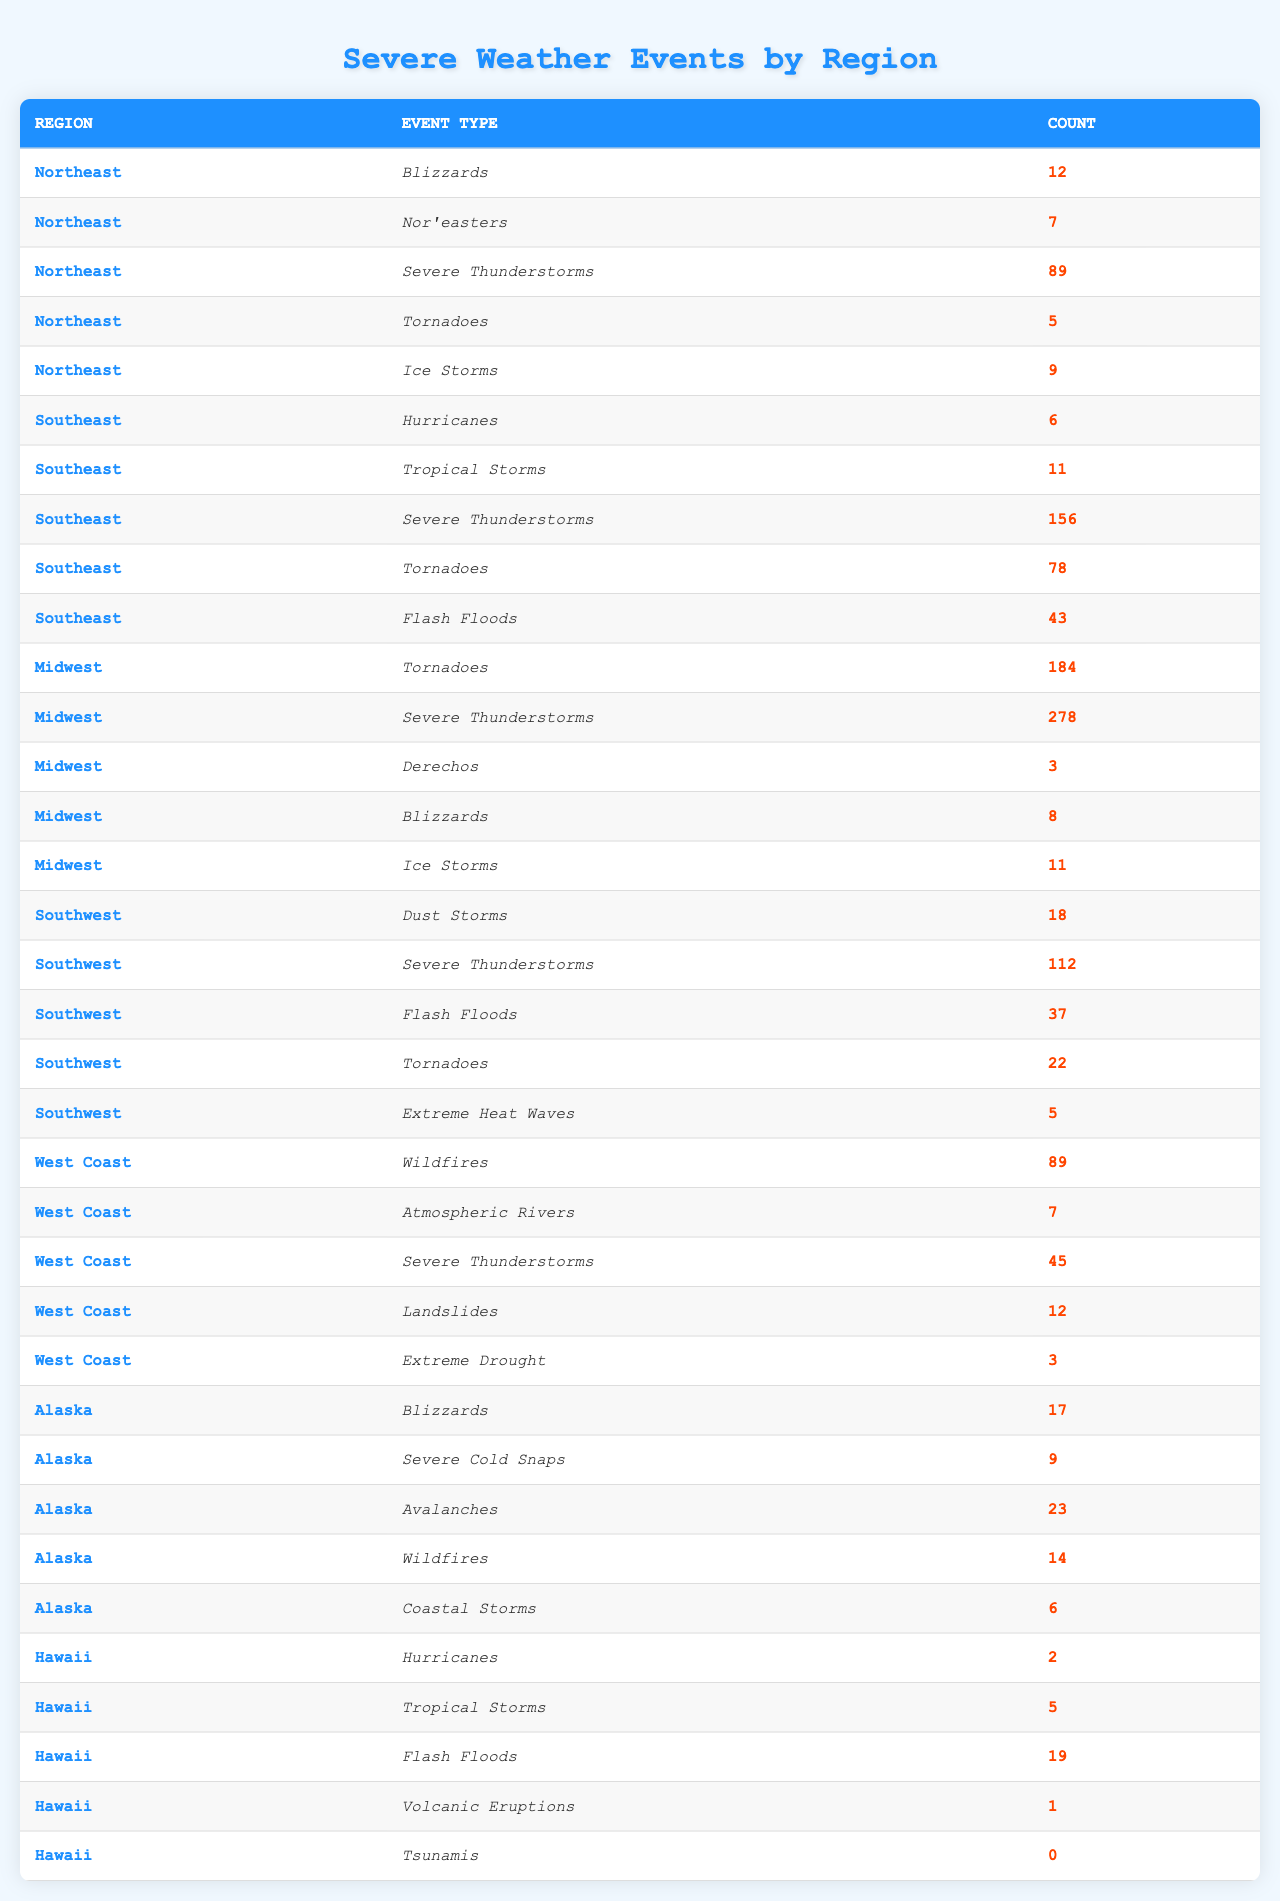What is the total number of severe thunderstorms reported in the Southeast? There are two entries for severe thunderstorms in the Southeast: 156 from Severe Thunderstorms and 78 from Tornadoes, which do not count as thunderstorms. So, the total for severe thunderstorms is simply 156.
Answer: 156 Which region experienced the highest number of tornadoes? In the table, the Midwest shows 184 tornadoes, more than any other region, as the Southeast has 78 and the Southwest has 22.
Answer: Midwest What is the total number of blizzards across all regions? In the Northeast there are 12 blizzards, in the Midwest there are 8, and in Alaska there are 17. Adding these gives 12 + 8 + 17 = 37.
Answer: 37 Were there any tornadoes reported in Hawaii? The table shows that Hawaii has no entries for tornadoes, as it only lists Hurricanes, Tropical Storms, Flash Floods, Volcanic Eruptions, and Tsunamis.
Answer: No Which region had the highest total count of severe weather events? First, we calculate the total events for each region: Northeast (122), Southeast (294), Midwest (484), Southwest (289), West Coast (156), Alaska (69), and Hawaii (27). The Midwest has the highest total with 484.
Answer: Midwest How many more severe thunderstorms occurred in the Southeast compared to the West Coast? The Southeast had 156 severe thunderstorms while the West Coast had 45. The difference is 156 - 45 = 111.
Answer: 111 What percentage of all reported tornadoes were in the Midwest? The Midwest reported 184 tornadoes, the Southeast reported 78, and the Southwest reported 22. The total is 184 + 78 + 22 = 284. So, the percentage for the Midwest is (184 / 284) * 100 ≈ 64.8%.
Answer: 64.8% Which type of severe weather event was most common in the Southwest? The count of severe thunderstorms in the Southwest is 112, which is higher than the counts for Tornadoes (22), Flash Floods (37), Dust Storms (18), and Extreme Heat Waves (5).
Answer: Severe Thunderstorms How many regions reported hurricanes, and what was the total count? The Southeast reported 6 hurricanes and Hawaii reported 2. The total count is 6 + 2 = 8 hurricanes across the two regions.
Answer: 8 If we consider only the severe cold snaps, which region experienced them, and how many were reported? The only region that experienced severe cold snaps is Alaska, which reported 9.
Answer: Alaska, 9 